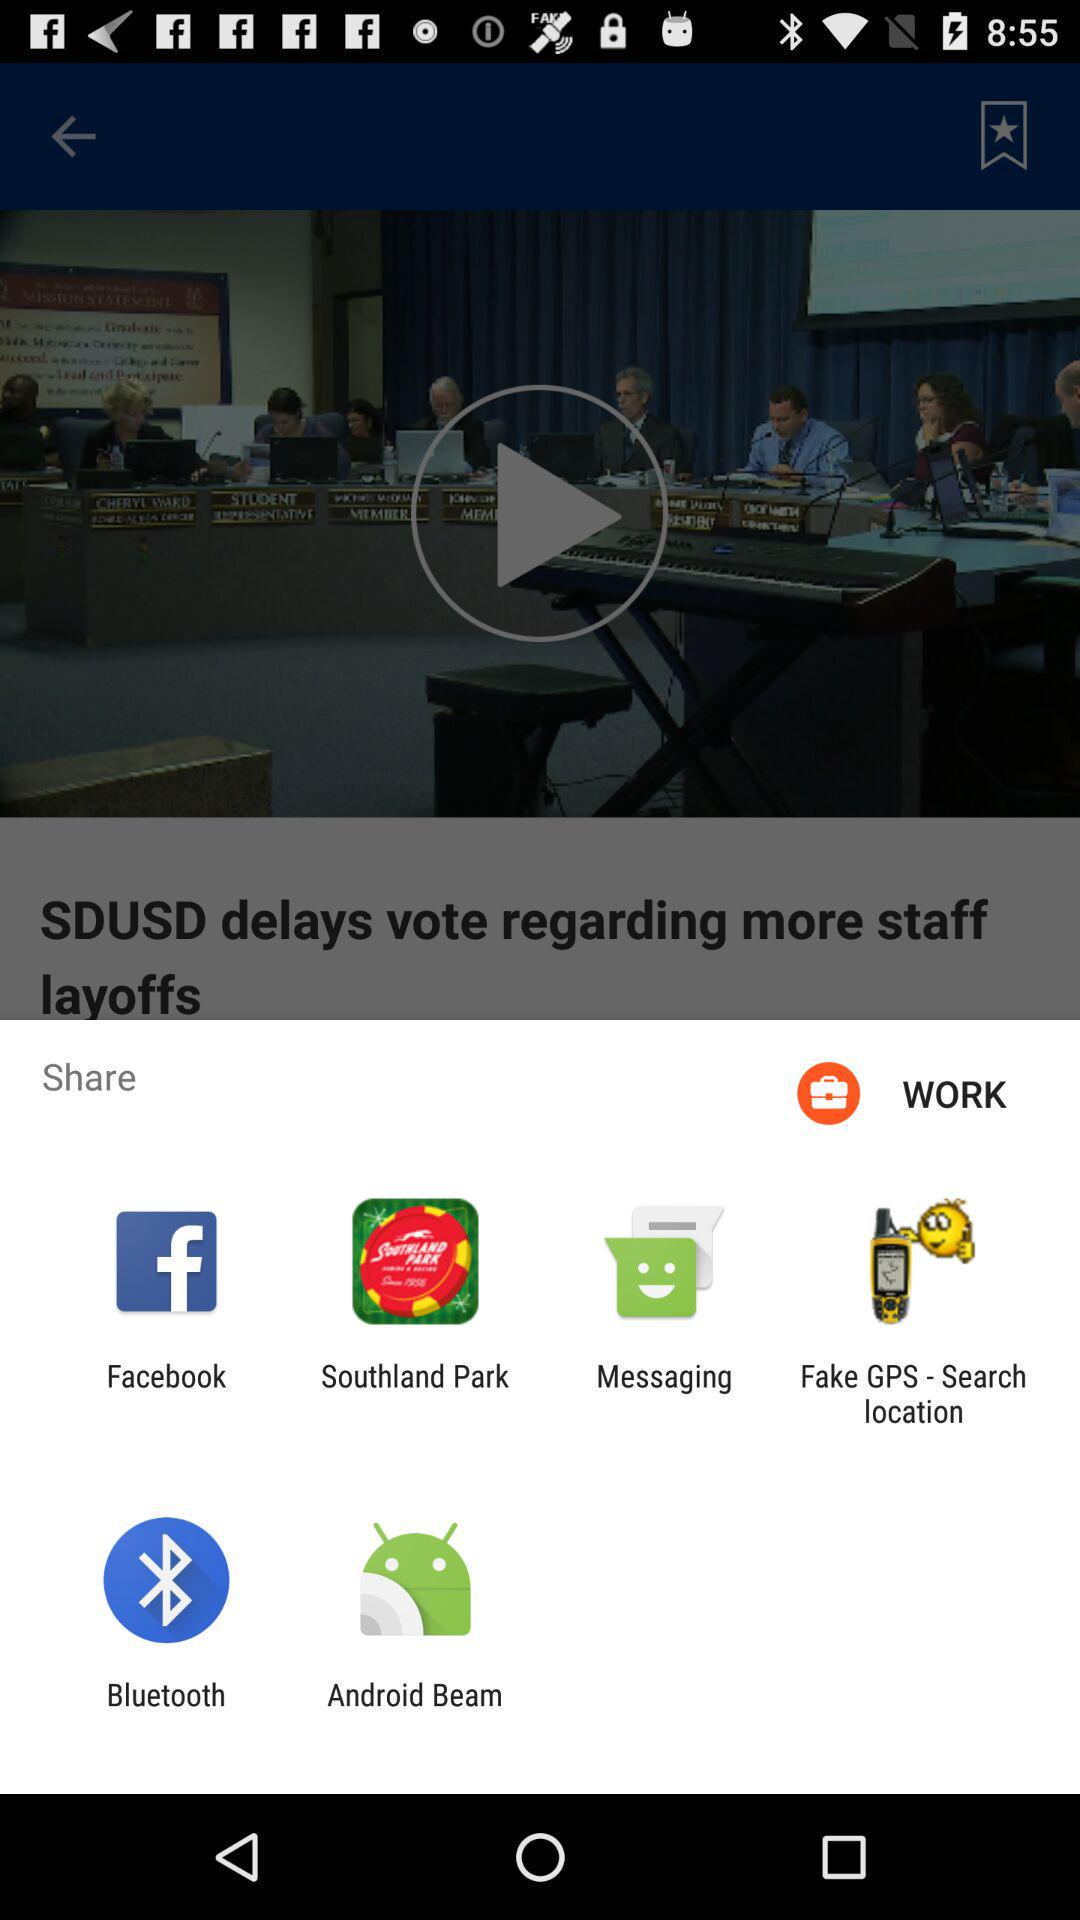What are the options available for sharing? The options are "Facebook", "Southland Park", "Messaging", "Fake GPS - Search location", "Bluetooth" and "Android Beam". 